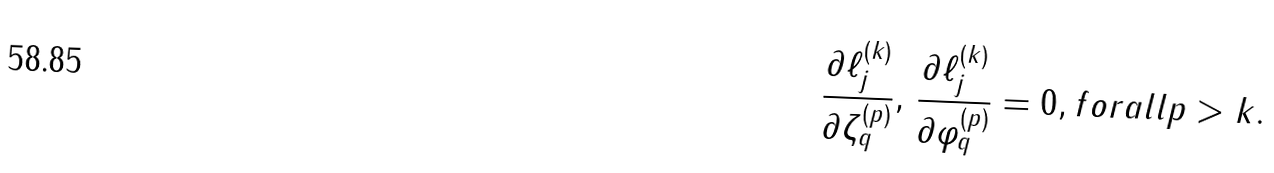Convert formula to latex. <formula><loc_0><loc_0><loc_500><loc_500>\frac { \partial \ell _ { j } ^ { ( k ) } } { \partial \zeta _ { q } ^ { ( p ) } } , \, \frac { \partial \ell _ { j } ^ { ( k ) } } { \partial \varphi _ { q } ^ { ( p ) } } = 0 , f o r a l l p > k .</formula> 